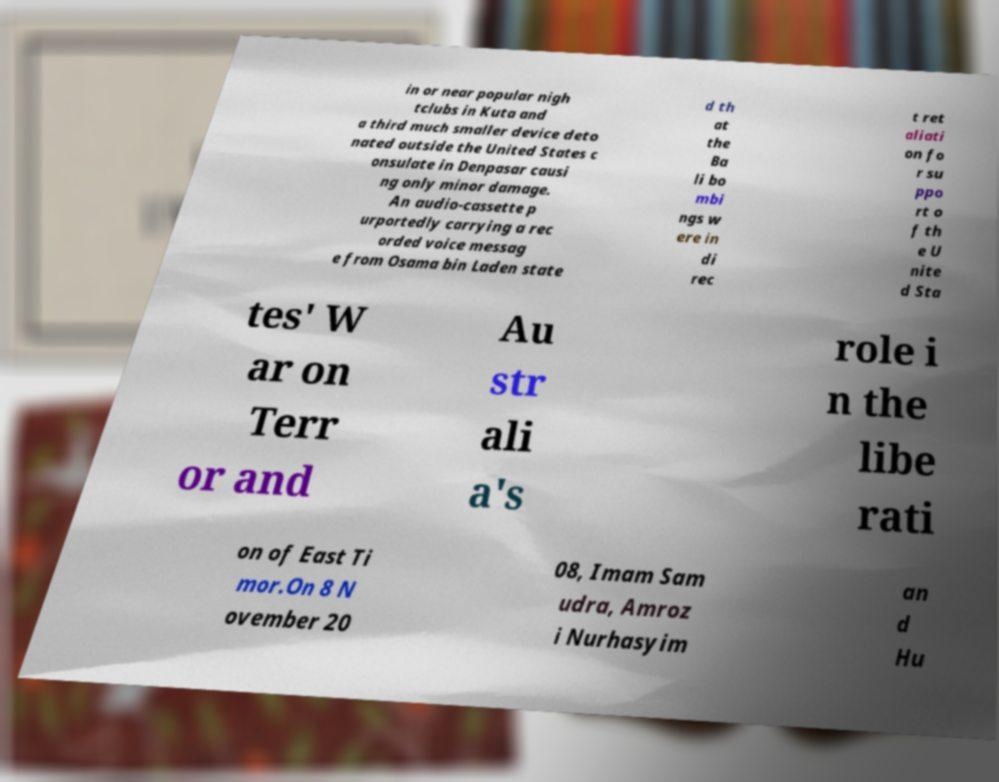What messages or text are displayed in this image? I need them in a readable, typed format. in or near popular nigh tclubs in Kuta and a third much smaller device deto nated outside the United States c onsulate in Denpasar causi ng only minor damage. An audio-cassette p urportedly carrying a rec orded voice messag e from Osama bin Laden state d th at the Ba li bo mbi ngs w ere in di rec t ret aliati on fo r su ppo rt o f th e U nite d Sta tes' W ar on Terr or and Au str ali a's role i n the libe rati on of East Ti mor.On 8 N ovember 20 08, Imam Sam udra, Amroz i Nurhasyim an d Hu 